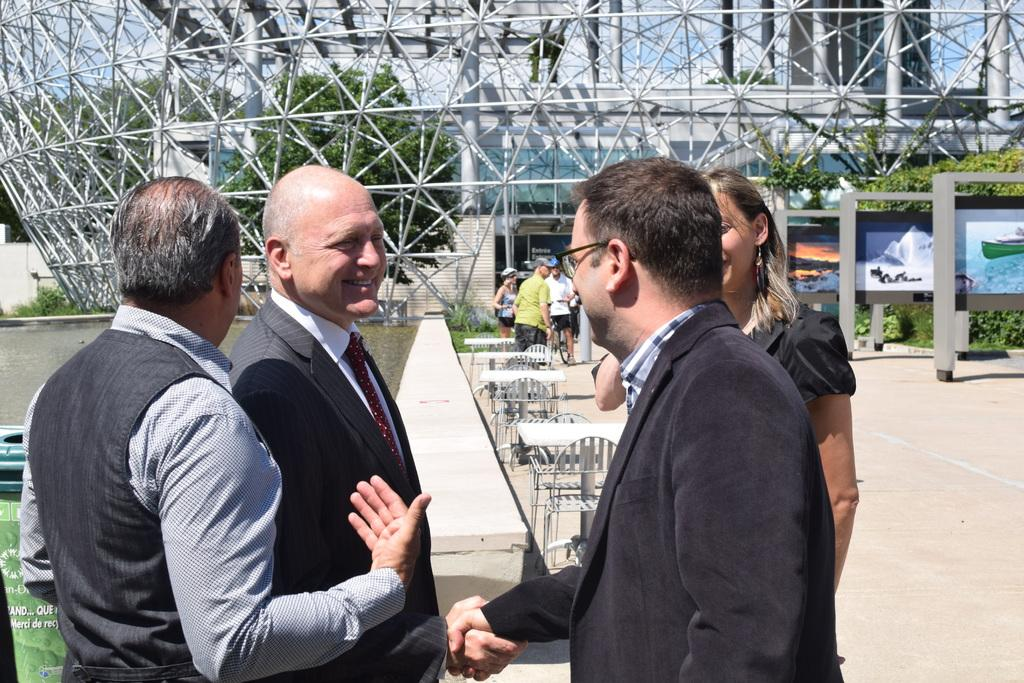What are the people in the image doing? Two people are shaking hands in the image. Can you describe the people in the background of the image? There are people in the background of the image. What type of furniture is visible in the background of the image? Tables and chairs are visible in the background of the image. What structure can be seen in the background of the image? There is a building in the background of the image. Where is the faucet located in the image? There is no faucet present in the image. What direction are the people pointing in the image? The image does not show any people pointing, so it cannot be determined from the image. 